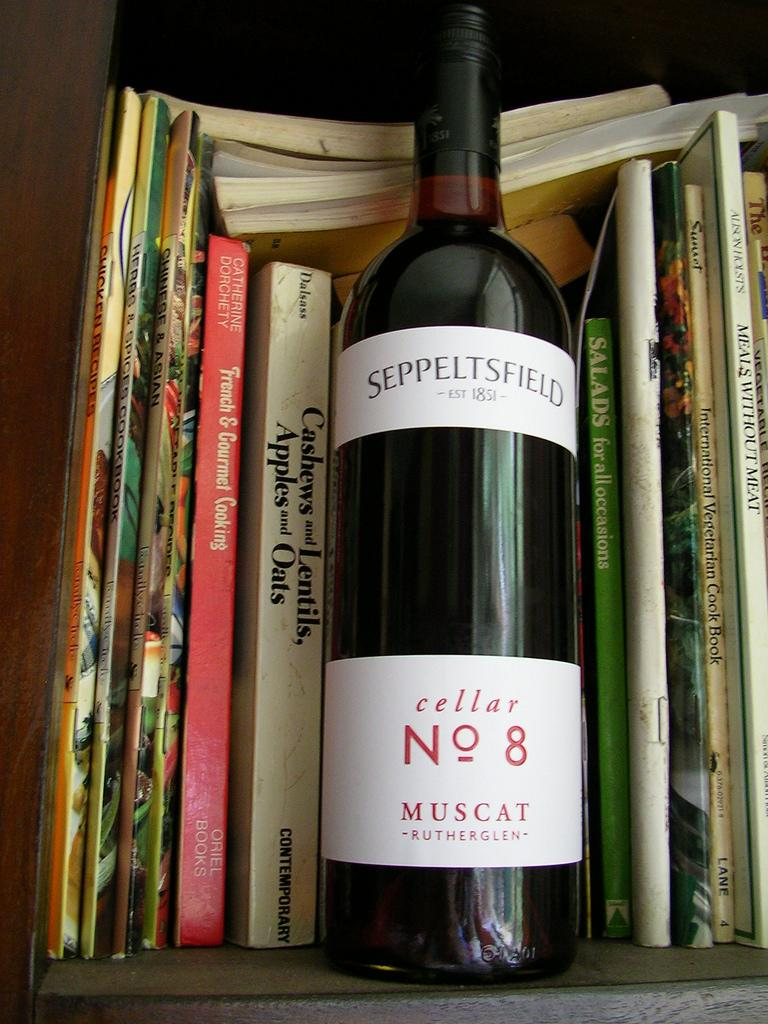<image>
Relay a brief, clear account of the picture shown. A bottle of Seppeltsfield, cellar No 8 is sitting in front of a stack of books 